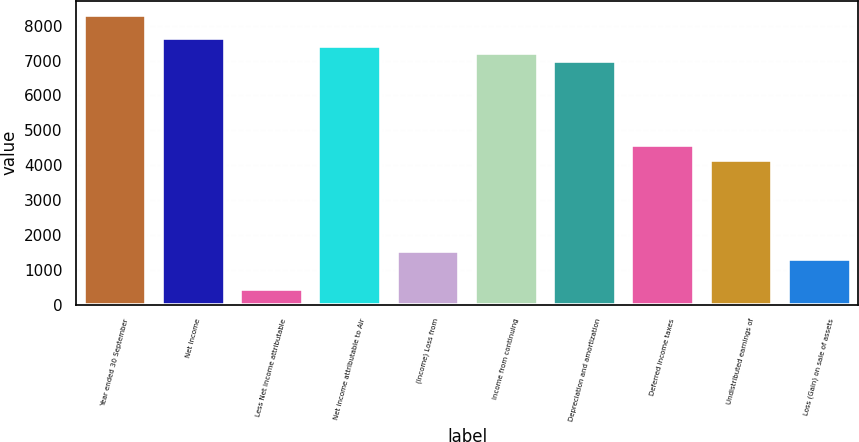Convert chart. <chart><loc_0><loc_0><loc_500><loc_500><bar_chart><fcel>Year ended 30 September<fcel>Net Income<fcel>Less Net income attributable<fcel>Net income attributable to Air<fcel>(Income) Loss from<fcel>Income from continuing<fcel>Depreciation and amortization<fcel>Deferred income taxes<fcel>Undistributed earnings of<fcel>Loss (Gain) on sale of assets<nl><fcel>8306.92<fcel>7651.15<fcel>437.68<fcel>7432.56<fcel>1530.63<fcel>7213.97<fcel>6995.38<fcel>4590.89<fcel>4153.71<fcel>1312.04<nl></chart> 